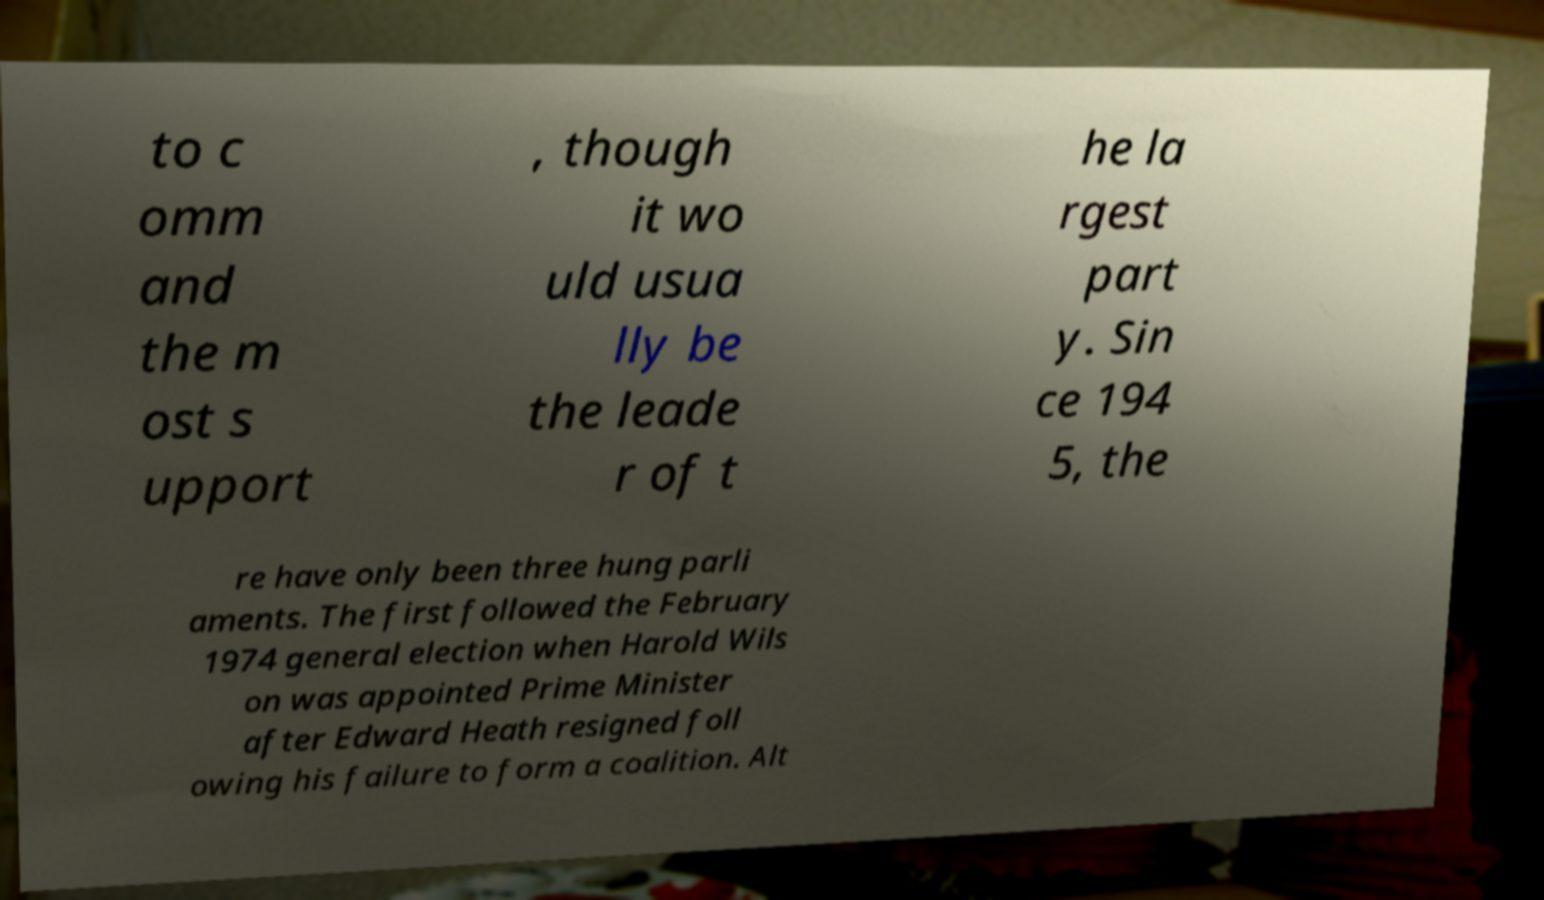I need the written content from this picture converted into text. Can you do that? to c omm and the m ost s upport , though it wo uld usua lly be the leade r of t he la rgest part y. Sin ce 194 5, the re have only been three hung parli aments. The first followed the February 1974 general election when Harold Wils on was appointed Prime Minister after Edward Heath resigned foll owing his failure to form a coalition. Alt 